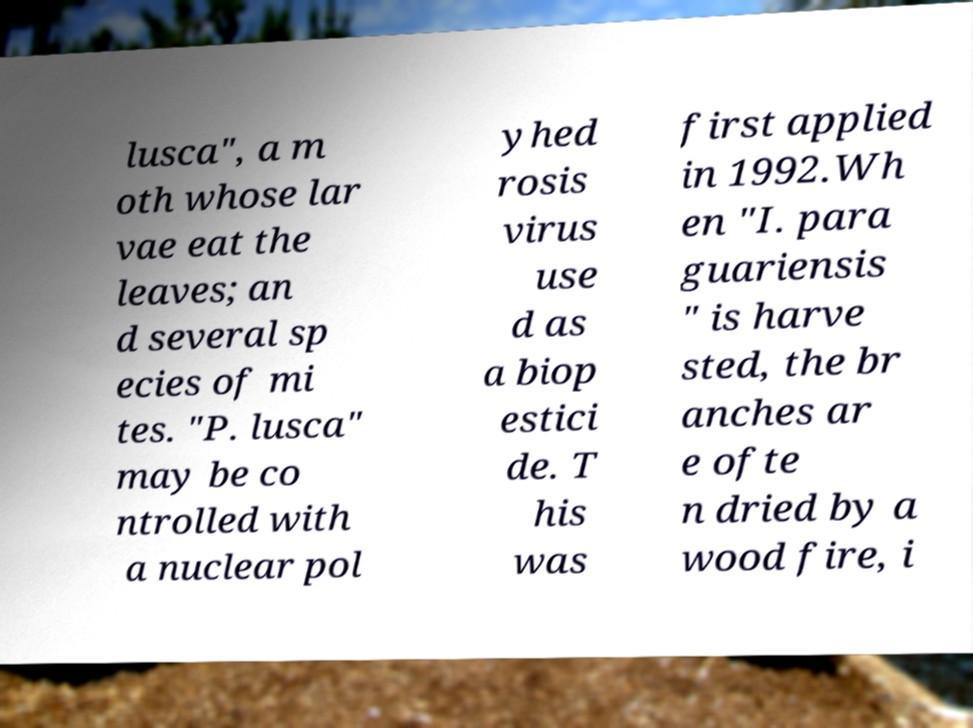Please identify and transcribe the text found in this image. lusca", a m oth whose lar vae eat the leaves; an d several sp ecies of mi tes. "P. lusca" may be co ntrolled with a nuclear pol yhed rosis virus use d as a biop estici de. T his was first applied in 1992.Wh en "I. para guariensis " is harve sted, the br anches ar e ofte n dried by a wood fire, i 